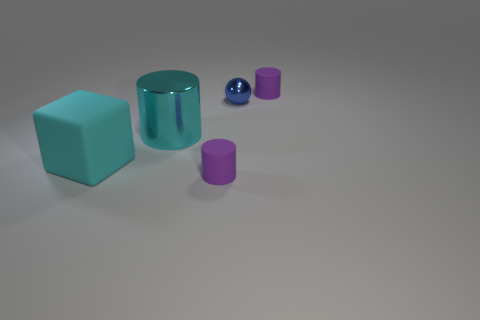Subtract all red cylinders. Subtract all blue balls. How many cylinders are left? 3 Add 2 cyan cubes. How many objects exist? 7 Subtract all cylinders. How many objects are left? 2 Subtract all big cyan cubes. Subtract all blocks. How many objects are left? 3 Add 4 big cyan rubber objects. How many big cyan rubber objects are left? 5 Add 5 big metallic cylinders. How many big metallic cylinders exist? 6 Subtract 0 brown spheres. How many objects are left? 5 